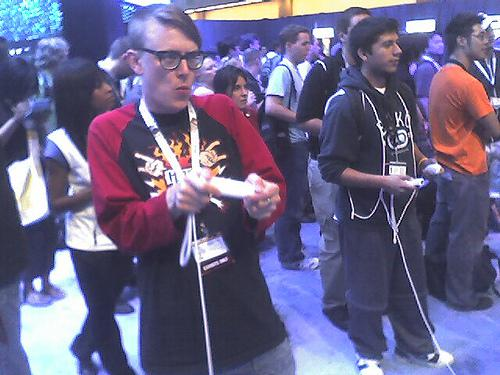Question: who is wearing glasses?
Choices:
A. Woman.
B. Boy.
C. Girl.
D. Man.
Answer with the letter. Answer: D Question: how many people are playing the game?
Choices:
A. 3.
B. 4.
C. 5.
D. 2.
Answer with the letter. Answer: D Question: what color are the man's glasses?
Choices:
A. Black.
B. Silver.
C. Brown.
D. Tan.
Answer with the letter. Answer: A 